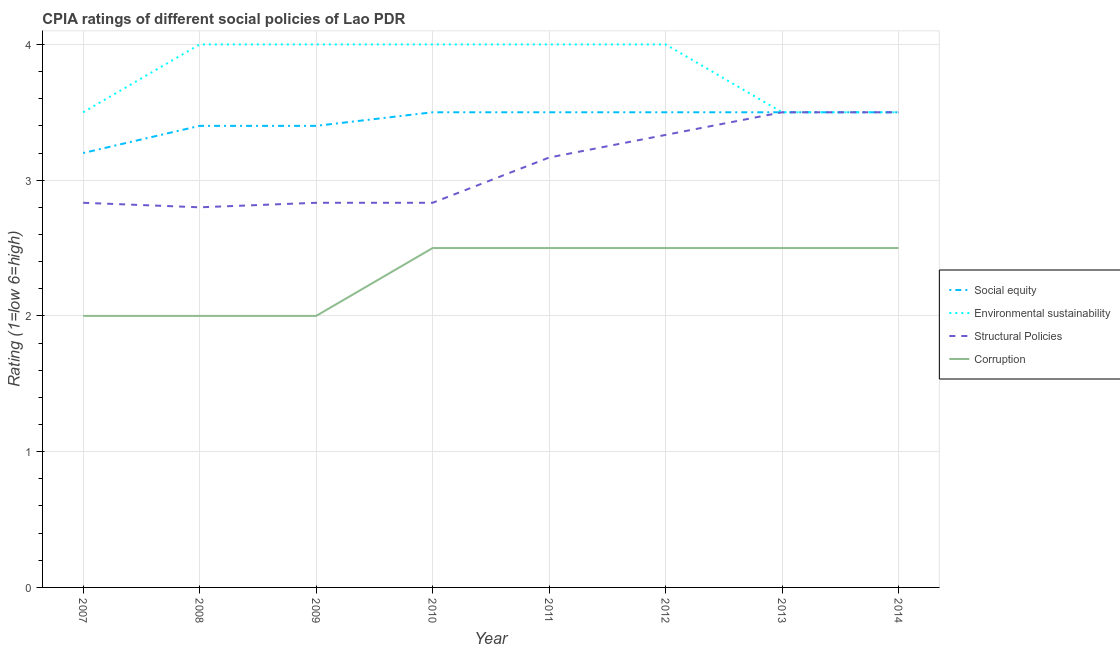How many different coloured lines are there?
Make the answer very short. 4. What is the cpia rating of corruption in 2014?
Give a very brief answer. 2.5. Across all years, what is the minimum cpia rating of structural policies?
Provide a short and direct response. 2.8. What is the total cpia rating of structural policies in the graph?
Your response must be concise. 24.8. What is the difference between the cpia rating of environmental sustainability in 2009 and that in 2012?
Provide a short and direct response. 0. What is the difference between the cpia rating of environmental sustainability in 2007 and the cpia rating of structural policies in 2010?
Ensure brevity in your answer.  0.67. What is the average cpia rating of social equity per year?
Offer a very short reply. 3.44. Is the difference between the cpia rating of environmental sustainability in 2009 and 2011 greater than the difference between the cpia rating of social equity in 2009 and 2011?
Your answer should be compact. Yes. What is the difference between the highest and the lowest cpia rating of social equity?
Ensure brevity in your answer.  0.3. In how many years, is the cpia rating of corruption greater than the average cpia rating of corruption taken over all years?
Your answer should be compact. 5. Is the sum of the cpia rating of environmental sustainability in 2008 and 2009 greater than the maximum cpia rating of corruption across all years?
Make the answer very short. Yes. Does the cpia rating of environmental sustainability monotonically increase over the years?
Offer a terse response. No. Is the cpia rating of corruption strictly less than the cpia rating of environmental sustainability over the years?
Keep it short and to the point. Yes. How many legend labels are there?
Your response must be concise. 4. How are the legend labels stacked?
Offer a very short reply. Vertical. What is the title of the graph?
Offer a terse response. CPIA ratings of different social policies of Lao PDR. What is the label or title of the Y-axis?
Make the answer very short. Rating (1=low 6=high). What is the Rating (1=low 6=high) of Structural Policies in 2007?
Provide a succinct answer. 2.83. What is the Rating (1=low 6=high) of Corruption in 2007?
Offer a very short reply. 2. What is the Rating (1=low 6=high) in Social equity in 2008?
Ensure brevity in your answer.  3.4. What is the Rating (1=low 6=high) in Environmental sustainability in 2008?
Your response must be concise. 4. What is the Rating (1=low 6=high) in Structural Policies in 2008?
Make the answer very short. 2.8. What is the Rating (1=low 6=high) in Environmental sustainability in 2009?
Your answer should be very brief. 4. What is the Rating (1=low 6=high) in Structural Policies in 2009?
Provide a short and direct response. 2.83. What is the Rating (1=low 6=high) in Structural Policies in 2010?
Your answer should be very brief. 2.83. What is the Rating (1=low 6=high) in Structural Policies in 2011?
Keep it short and to the point. 3.17. What is the Rating (1=low 6=high) of Environmental sustainability in 2012?
Your response must be concise. 4. What is the Rating (1=low 6=high) in Structural Policies in 2012?
Keep it short and to the point. 3.33. What is the Rating (1=low 6=high) in Social equity in 2013?
Ensure brevity in your answer.  3.5. What is the Rating (1=low 6=high) of Corruption in 2013?
Your response must be concise. 2.5. What is the Rating (1=low 6=high) in Structural Policies in 2014?
Your answer should be very brief. 3.5. Across all years, what is the maximum Rating (1=low 6=high) of Social equity?
Offer a terse response. 3.5. Across all years, what is the maximum Rating (1=low 6=high) in Structural Policies?
Make the answer very short. 3.5. Across all years, what is the maximum Rating (1=low 6=high) of Corruption?
Provide a short and direct response. 2.5. Across all years, what is the minimum Rating (1=low 6=high) in Environmental sustainability?
Give a very brief answer. 3.5. Across all years, what is the minimum Rating (1=low 6=high) in Structural Policies?
Offer a very short reply. 2.8. What is the total Rating (1=low 6=high) in Environmental sustainability in the graph?
Keep it short and to the point. 30.5. What is the total Rating (1=low 6=high) of Structural Policies in the graph?
Provide a short and direct response. 24.8. What is the difference between the Rating (1=low 6=high) in Environmental sustainability in 2007 and that in 2008?
Ensure brevity in your answer.  -0.5. What is the difference between the Rating (1=low 6=high) of Corruption in 2007 and that in 2008?
Make the answer very short. 0. What is the difference between the Rating (1=low 6=high) of Social equity in 2007 and that in 2009?
Give a very brief answer. -0.2. What is the difference between the Rating (1=low 6=high) in Corruption in 2007 and that in 2009?
Offer a very short reply. 0. What is the difference between the Rating (1=low 6=high) of Environmental sustainability in 2007 and that in 2010?
Your response must be concise. -0.5. What is the difference between the Rating (1=low 6=high) in Structural Policies in 2007 and that in 2010?
Make the answer very short. 0. What is the difference between the Rating (1=low 6=high) in Social equity in 2007 and that in 2011?
Your answer should be compact. -0.3. What is the difference between the Rating (1=low 6=high) in Structural Policies in 2007 and that in 2011?
Make the answer very short. -0.33. What is the difference between the Rating (1=low 6=high) in Environmental sustainability in 2007 and that in 2012?
Offer a terse response. -0.5. What is the difference between the Rating (1=low 6=high) of Corruption in 2007 and that in 2012?
Your answer should be very brief. -0.5. What is the difference between the Rating (1=low 6=high) in Environmental sustainability in 2007 and that in 2013?
Your answer should be compact. 0. What is the difference between the Rating (1=low 6=high) in Corruption in 2007 and that in 2013?
Give a very brief answer. -0.5. What is the difference between the Rating (1=low 6=high) in Social equity in 2007 and that in 2014?
Your response must be concise. -0.3. What is the difference between the Rating (1=low 6=high) of Social equity in 2008 and that in 2009?
Ensure brevity in your answer.  0. What is the difference between the Rating (1=low 6=high) of Structural Policies in 2008 and that in 2009?
Offer a very short reply. -0.03. What is the difference between the Rating (1=low 6=high) in Social equity in 2008 and that in 2010?
Your answer should be very brief. -0.1. What is the difference between the Rating (1=low 6=high) of Structural Policies in 2008 and that in 2010?
Ensure brevity in your answer.  -0.03. What is the difference between the Rating (1=low 6=high) of Social equity in 2008 and that in 2011?
Give a very brief answer. -0.1. What is the difference between the Rating (1=low 6=high) of Environmental sustainability in 2008 and that in 2011?
Ensure brevity in your answer.  0. What is the difference between the Rating (1=low 6=high) of Structural Policies in 2008 and that in 2011?
Your response must be concise. -0.37. What is the difference between the Rating (1=low 6=high) in Corruption in 2008 and that in 2011?
Ensure brevity in your answer.  -0.5. What is the difference between the Rating (1=low 6=high) of Social equity in 2008 and that in 2012?
Ensure brevity in your answer.  -0.1. What is the difference between the Rating (1=low 6=high) of Environmental sustainability in 2008 and that in 2012?
Give a very brief answer. 0. What is the difference between the Rating (1=low 6=high) of Structural Policies in 2008 and that in 2012?
Offer a terse response. -0.53. What is the difference between the Rating (1=low 6=high) of Environmental sustainability in 2008 and that in 2013?
Offer a very short reply. 0.5. What is the difference between the Rating (1=low 6=high) in Corruption in 2008 and that in 2013?
Offer a very short reply. -0.5. What is the difference between the Rating (1=low 6=high) of Environmental sustainability in 2008 and that in 2014?
Your answer should be compact. 0.5. What is the difference between the Rating (1=low 6=high) of Corruption in 2008 and that in 2014?
Make the answer very short. -0.5. What is the difference between the Rating (1=low 6=high) in Social equity in 2009 and that in 2010?
Offer a terse response. -0.1. What is the difference between the Rating (1=low 6=high) in Environmental sustainability in 2009 and that in 2010?
Offer a very short reply. 0. What is the difference between the Rating (1=low 6=high) of Corruption in 2009 and that in 2010?
Provide a succinct answer. -0.5. What is the difference between the Rating (1=low 6=high) in Social equity in 2009 and that in 2011?
Provide a succinct answer. -0.1. What is the difference between the Rating (1=low 6=high) in Structural Policies in 2009 and that in 2011?
Keep it short and to the point. -0.33. What is the difference between the Rating (1=low 6=high) of Corruption in 2009 and that in 2011?
Provide a short and direct response. -0.5. What is the difference between the Rating (1=low 6=high) in Social equity in 2009 and that in 2012?
Keep it short and to the point. -0.1. What is the difference between the Rating (1=low 6=high) in Environmental sustainability in 2009 and that in 2012?
Provide a succinct answer. 0. What is the difference between the Rating (1=low 6=high) in Corruption in 2009 and that in 2012?
Your answer should be very brief. -0.5. What is the difference between the Rating (1=low 6=high) in Structural Policies in 2009 and that in 2013?
Keep it short and to the point. -0.67. What is the difference between the Rating (1=low 6=high) in Social equity in 2009 and that in 2014?
Give a very brief answer. -0.1. What is the difference between the Rating (1=low 6=high) of Structural Policies in 2009 and that in 2014?
Give a very brief answer. -0.67. What is the difference between the Rating (1=low 6=high) of Social equity in 2010 and that in 2011?
Your response must be concise. 0. What is the difference between the Rating (1=low 6=high) in Environmental sustainability in 2010 and that in 2011?
Ensure brevity in your answer.  0. What is the difference between the Rating (1=low 6=high) of Structural Policies in 2010 and that in 2011?
Your answer should be compact. -0.33. What is the difference between the Rating (1=low 6=high) of Corruption in 2010 and that in 2011?
Your answer should be compact. 0. What is the difference between the Rating (1=low 6=high) of Environmental sustainability in 2010 and that in 2012?
Ensure brevity in your answer.  0. What is the difference between the Rating (1=low 6=high) of Corruption in 2010 and that in 2012?
Your response must be concise. 0. What is the difference between the Rating (1=low 6=high) of Environmental sustainability in 2010 and that in 2013?
Your response must be concise. 0.5. What is the difference between the Rating (1=low 6=high) in Structural Policies in 2010 and that in 2013?
Your response must be concise. -0.67. What is the difference between the Rating (1=low 6=high) in Corruption in 2010 and that in 2013?
Provide a short and direct response. 0. What is the difference between the Rating (1=low 6=high) of Social equity in 2010 and that in 2014?
Keep it short and to the point. 0. What is the difference between the Rating (1=low 6=high) of Structural Policies in 2010 and that in 2014?
Offer a very short reply. -0.67. What is the difference between the Rating (1=low 6=high) in Social equity in 2011 and that in 2012?
Your answer should be compact. 0. What is the difference between the Rating (1=low 6=high) in Environmental sustainability in 2011 and that in 2013?
Your answer should be compact. 0.5. What is the difference between the Rating (1=low 6=high) of Social equity in 2011 and that in 2014?
Provide a short and direct response. 0. What is the difference between the Rating (1=low 6=high) of Environmental sustainability in 2011 and that in 2014?
Provide a succinct answer. 0.5. What is the difference between the Rating (1=low 6=high) of Corruption in 2011 and that in 2014?
Your answer should be very brief. 0. What is the difference between the Rating (1=low 6=high) in Corruption in 2012 and that in 2014?
Give a very brief answer. 0. What is the difference between the Rating (1=low 6=high) in Social equity in 2013 and that in 2014?
Offer a very short reply. 0. What is the difference between the Rating (1=low 6=high) of Social equity in 2007 and the Rating (1=low 6=high) of Structural Policies in 2008?
Offer a very short reply. 0.4. What is the difference between the Rating (1=low 6=high) in Social equity in 2007 and the Rating (1=low 6=high) in Corruption in 2008?
Your answer should be compact. 1.2. What is the difference between the Rating (1=low 6=high) of Environmental sustainability in 2007 and the Rating (1=low 6=high) of Structural Policies in 2008?
Offer a terse response. 0.7. What is the difference between the Rating (1=low 6=high) of Environmental sustainability in 2007 and the Rating (1=low 6=high) of Corruption in 2008?
Offer a very short reply. 1.5. What is the difference between the Rating (1=low 6=high) in Structural Policies in 2007 and the Rating (1=low 6=high) in Corruption in 2008?
Keep it short and to the point. 0.83. What is the difference between the Rating (1=low 6=high) of Social equity in 2007 and the Rating (1=low 6=high) of Environmental sustainability in 2009?
Ensure brevity in your answer.  -0.8. What is the difference between the Rating (1=low 6=high) in Social equity in 2007 and the Rating (1=low 6=high) in Structural Policies in 2009?
Ensure brevity in your answer.  0.37. What is the difference between the Rating (1=low 6=high) of Environmental sustainability in 2007 and the Rating (1=low 6=high) of Structural Policies in 2009?
Offer a very short reply. 0.67. What is the difference between the Rating (1=low 6=high) of Environmental sustainability in 2007 and the Rating (1=low 6=high) of Corruption in 2009?
Provide a succinct answer. 1.5. What is the difference between the Rating (1=low 6=high) of Social equity in 2007 and the Rating (1=low 6=high) of Structural Policies in 2010?
Your response must be concise. 0.37. What is the difference between the Rating (1=low 6=high) in Social equity in 2007 and the Rating (1=low 6=high) in Corruption in 2010?
Ensure brevity in your answer.  0.7. What is the difference between the Rating (1=low 6=high) in Environmental sustainability in 2007 and the Rating (1=low 6=high) in Structural Policies in 2010?
Your answer should be very brief. 0.67. What is the difference between the Rating (1=low 6=high) in Structural Policies in 2007 and the Rating (1=low 6=high) in Corruption in 2010?
Your response must be concise. 0.33. What is the difference between the Rating (1=low 6=high) in Social equity in 2007 and the Rating (1=low 6=high) in Environmental sustainability in 2011?
Your answer should be very brief. -0.8. What is the difference between the Rating (1=low 6=high) of Environmental sustainability in 2007 and the Rating (1=low 6=high) of Structural Policies in 2011?
Provide a succinct answer. 0.33. What is the difference between the Rating (1=low 6=high) in Environmental sustainability in 2007 and the Rating (1=low 6=high) in Corruption in 2011?
Provide a succinct answer. 1. What is the difference between the Rating (1=low 6=high) of Structural Policies in 2007 and the Rating (1=low 6=high) of Corruption in 2011?
Offer a very short reply. 0.33. What is the difference between the Rating (1=low 6=high) in Social equity in 2007 and the Rating (1=low 6=high) in Structural Policies in 2012?
Provide a succinct answer. -0.13. What is the difference between the Rating (1=low 6=high) of Environmental sustainability in 2007 and the Rating (1=low 6=high) of Corruption in 2012?
Offer a very short reply. 1. What is the difference between the Rating (1=low 6=high) of Structural Policies in 2007 and the Rating (1=low 6=high) of Corruption in 2012?
Make the answer very short. 0.33. What is the difference between the Rating (1=low 6=high) of Social equity in 2007 and the Rating (1=low 6=high) of Environmental sustainability in 2013?
Provide a short and direct response. -0.3. What is the difference between the Rating (1=low 6=high) in Environmental sustainability in 2007 and the Rating (1=low 6=high) in Corruption in 2013?
Your response must be concise. 1. What is the difference between the Rating (1=low 6=high) in Social equity in 2007 and the Rating (1=low 6=high) in Corruption in 2014?
Ensure brevity in your answer.  0.7. What is the difference between the Rating (1=low 6=high) in Environmental sustainability in 2007 and the Rating (1=low 6=high) in Structural Policies in 2014?
Your response must be concise. 0. What is the difference between the Rating (1=low 6=high) in Environmental sustainability in 2007 and the Rating (1=low 6=high) in Corruption in 2014?
Your response must be concise. 1. What is the difference between the Rating (1=low 6=high) in Structural Policies in 2007 and the Rating (1=low 6=high) in Corruption in 2014?
Keep it short and to the point. 0.33. What is the difference between the Rating (1=low 6=high) in Social equity in 2008 and the Rating (1=low 6=high) in Environmental sustainability in 2009?
Provide a short and direct response. -0.6. What is the difference between the Rating (1=low 6=high) of Social equity in 2008 and the Rating (1=low 6=high) of Structural Policies in 2009?
Make the answer very short. 0.57. What is the difference between the Rating (1=low 6=high) of Environmental sustainability in 2008 and the Rating (1=low 6=high) of Structural Policies in 2009?
Your answer should be very brief. 1.17. What is the difference between the Rating (1=low 6=high) in Structural Policies in 2008 and the Rating (1=low 6=high) in Corruption in 2009?
Ensure brevity in your answer.  0.8. What is the difference between the Rating (1=low 6=high) of Social equity in 2008 and the Rating (1=low 6=high) of Structural Policies in 2010?
Your answer should be compact. 0.57. What is the difference between the Rating (1=low 6=high) of Environmental sustainability in 2008 and the Rating (1=low 6=high) of Structural Policies in 2010?
Provide a short and direct response. 1.17. What is the difference between the Rating (1=low 6=high) in Social equity in 2008 and the Rating (1=low 6=high) in Environmental sustainability in 2011?
Offer a terse response. -0.6. What is the difference between the Rating (1=low 6=high) in Social equity in 2008 and the Rating (1=low 6=high) in Structural Policies in 2011?
Offer a terse response. 0.23. What is the difference between the Rating (1=low 6=high) of Social equity in 2008 and the Rating (1=low 6=high) of Corruption in 2011?
Provide a succinct answer. 0.9. What is the difference between the Rating (1=low 6=high) of Social equity in 2008 and the Rating (1=low 6=high) of Environmental sustainability in 2012?
Give a very brief answer. -0.6. What is the difference between the Rating (1=low 6=high) in Social equity in 2008 and the Rating (1=low 6=high) in Structural Policies in 2012?
Keep it short and to the point. 0.07. What is the difference between the Rating (1=low 6=high) of Social equity in 2008 and the Rating (1=low 6=high) of Corruption in 2012?
Make the answer very short. 0.9. What is the difference between the Rating (1=low 6=high) in Environmental sustainability in 2008 and the Rating (1=low 6=high) in Structural Policies in 2012?
Make the answer very short. 0.67. What is the difference between the Rating (1=low 6=high) of Structural Policies in 2008 and the Rating (1=low 6=high) of Corruption in 2012?
Your answer should be compact. 0.3. What is the difference between the Rating (1=low 6=high) of Social equity in 2008 and the Rating (1=low 6=high) of Environmental sustainability in 2013?
Offer a terse response. -0.1. What is the difference between the Rating (1=low 6=high) in Structural Policies in 2008 and the Rating (1=low 6=high) in Corruption in 2013?
Provide a short and direct response. 0.3. What is the difference between the Rating (1=low 6=high) of Social equity in 2008 and the Rating (1=low 6=high) of Environmental sustainability in 2014?
Ensure brevity in your answer.  -0.1. What is the difference between the Rating (1=low 6=high) of Social equity in 2008 and the Rating (1=low 6=high) of Structural Policies in 2014?
Give a very brief answer. -0.1. What is the difference between the Rating (1=low 6=high) in Social equity in 2008 and the Rating (1=low 6=high) in Corruption in 2014?
Your answer should be compact. 0.9. What is the difference between the Rating (1=low 6=high) of Social equity in 2009 and the Rating (1=low 6=high) of Environmental sustainability in 2010?
Offer a very short reply. -0.6. What is the difference between the Rating (1=low 6=high) of Social equity in 2009 and the Rating (1=low 6=high) of Structural Policies in 2010?
Your answer should be compact. 0.57. What is the difference between the Rating (1=low 6=high) in Social equity in 2009 and the Rating (1=low 6=high) in Corruption in 2010?
Provide a succinct answer. 0.9. What is the difference between the Rating (1=low 6=high) of Environmental sustainability in 2009 and the Rating (1=low 6=high) of Corruption in 2010?
Keep it short and to the point. 1.5. What is the difference between the Rating (1=low 6=high) in Structural Policies in 2009 and the Rating (1=low 6=high) in Corruption in 2010?
Ensure brevity in your answer.  0.33. What is the difference between the Rating (1=low 6=high) in Social equity in 2009 and the Rating (1=low 6=high) in Environmental sustainability in 2011?
Make the answer very short. -0.6. What is the difference between the Rating (1=low 6=high) in Social equity in 2009 and the Rating (1=low 6=high) in Structural Policies in 2011?
Give a very brief answer. 0.23. What is the difference between the Rating (1=low 6=high) in Social equity in 2009 and the Rating (1=low 6=high) in Corruption in 2011?
Make the answer very short. 0.9. What is the difference between the Rating (1=low 6=high) in Environmental sustainability in 2009 and the Rating (1=low 6=high) in Corruption in 2011?
Provide a succinct answer. 1.5. What is the difference between the Rating (1=low 6=high) in Structural Policies in 2009 and the Rating (1=low 6=high) in Corruption in 2011?
Your answer should be compact. 0.33. What is the difference between the Rating (1=low 6=high) in Social equity in 2009 and the Rating (1=low 6=high) in Structural Policies in 2012?
Offer a terse response. 0.07. What is the difference between the Rating (1=low 6=high) in Environmental sustainability in 2009 and the Rating (1=low 6=high) in Structural Policies in 2012?
Offer a very short reply. 0.67. What is the difference between the Rating (1=low 6=high) of Structural Policies in 2009 and the Rating (1=low 6=high) of Corruption in 2012?
Ensure brevity in your answer.  0.33. What is the difference between the Rating (1=low 6=high) of Social equity in 2009 and the Rating (1=low 6=high) of Structural Policies in 2013?
Your answer should be compact. -0.1. What is the difference between the Rating (1=low 6=high) of Structural Policies in 2009 and the Rating (1=low 6=high) of Corruption in 2013?
Your response must be concise. 0.33. What is the difference between the Rating (1=low 6=high) in Social equity in 2009 and the Rating (1=low 6=high) in Structural Policies in 2014?
Give a very brief answer. -0.1. What is the difference between the Rating (1=low 6=high) of Environmental sustainability in 2009 and the Rating (1=low 6=high) of Corruption in 2014?
Your answer should be very brief. 1.5. What is the difference between the Rating (1=low 6=high) in Structural Policies in 2009 and the Rating (1=low 6=high) in Corruption in 2014?
Your answer should be very brief. 0.33. What is the difference between the Rating (1=low 6=high) of Environmental sustainability in 2010 and the Rating (1=low 6=high) of Structural Policies in 2011?
Your response must be concise. 0.83. What is the difference between the Rating (1=low 6=high) in Social equity in 2010 and the Rating (1=low 6=high) in Environmental sustainability in 2012?
Your response must be concise. -0.5. What is the difference between the Rating (1=low 6=high) in Social equity in 2010 and the Rating (1=low 6=high) in Corruption in 2012?
Offer a very short reply. 1. What is the difference between the Rating (1=low 6=high) in Environmental sustainability in 2010 and the Rating (1=low 6=high) in Corruption in 2012?
Offer a terse response. 1.5. What is the difference between the Rating (1=low 6=high) in Social equity in 2010 and the Rating (1=low 6=high) in Environmental sustainability in 2013?
Your answer should be compact. 0. What is the difference between the Rating (1=low 6=high) in Social equity in 2010 and the Rating (1=low 6=high) in Structural Policies in 2013?
Your answer should be very brief. 0. What is the difference between the Rating (1=low 6=high) in Social equity in 2010 and the Rating (1=low 6=high) in Corruption in 2013?
Give a very brief answer. 1. What is the difference between the Rating (1=low 6=high) of Social equity in 2010 and the Rating (1=low 6=high) of Structural Policies in 2014?
Offer a very short reply. 0. What is the difference between the Rating (1=low 6=high) in Environmental sustainability in 2010 and the Rating (1=low 6=high) in Corruption in 2014?
Make the answer very short. 1.5. What is the difference between the Rating (1=low 6=high) in Structural Policies in 2010 and the Rating (1=low 6=high) in Corruption in 2014?
Provide a short and direct response. 0.33. What is the difference between the Rating (1=low 6=high) in Social equity in 2011 and the Rating (1=low 6=high) in Environmental sustainability in 2012?
Make the answer very short. -0.5. What is the difference between the Rating (1=low 6=high) in Social equity in 2011 and the Rating (1=low 6=high) in Corruption in 2012?
Ensure brevity in your answer.  1. What is the difference between the Rating (1=low 6=high) in Environmental sustainability in 2011 and the Rating (1=low 6=high) in Structural Policies in 2012?
Offer a terse response. 0.67. What is the difference between the Rating (1=low 6=high) in Environmental sustainability in 2011 and the Rating (1=low 6=high) in Corruption in 2012?
Your response must be concise. 1.5. What is the difference between the Rating (1=low 6=high) of Social equity in 2011 and the Rating (1=low 6=high) of Environmental sustainability in 2013?
Ensure brevity in your answer.  0. What is the difference between the Rating (1=low 6=high) in Social equity in 2011 and the Rating (1=low 6=high) in Structural Policies in 2013?
Ensure brevity in your answer.  0. What is the difference between the Rating (1=low 6=high) of Environmental sustainability in 2011 and the Rating (1=low 6=high) of Structural Policies in 2013?
Keep it short and to the point. 0.5. What is the difference between the Rating (1=low 6=high) in Social equity in 2011 and the Rating (1=low 6=high) in Structural Policies in 2014?
Your response must be concise. 0. What is the difference between the Rating (1=low 6=high) in Social equity in 2012 and the Rating (1=low 6=high) in Structural Policies in 2013?
Your answer should be very brief. 0. What is the difference between the Rating (1=low 6=high) of Social equity in 2012 and the Rating (1=low 6=high) of Corruption in 2013?
Give a very brief answer. 1. What is the difference between the Rating (1=low 6=high) of Environmental sustainability in 2012 and the Rating (1=low 6=high) of Structural Policies in 2013?
Your answer should be compact. 0.5. What is the difference between the Rating (1=low 6=high) in Environmental sustainability in 2012 and the Rating (1=low 6=high) in Corruption in 2013?
Provide a short and direct response. 1.5. What is the difference between the Rating (1=low 6=high) of Structural Policies in 2012 and the Rating (1=low 6=high) of Corruption in 2013?
Provide a succinct answer. 0.83. What is the difference between the Rating (1=low 6=high) of Social equity in 2012 and the Rating (1=low 6=high) of Environmental sustainability in 2014?
Ensure brevity in your answer.  0. What is the difference between the Rating (1=low 6=high) in Social equity in 2012 and the Rating (1=low 6=high) in Corruption in 2014?
Offer a terse response. 1. What is the difference between the Rating (1=low 6=high) of Structural Policies in 2012 and the Rating (1=low 6=high) of Corruption in 2014?
Offer a very short reply. 0.83. What is the difference between the Rating (1=low 6=high) in Social equity in 2013 and the Rating (1=low 6=high) in Corruption in 2014?
Offer a very short reply. 1. What is the difference between the Rating (1=low 6=high) of Structural Policies in 2013 and the Rating (1=low 6=high) of Corruption in 2014?
Provide a succinct answer. 1. What is the average Rating (1=low 6=high) of Social equity per year?
Give a very brief answer. 3.44. What is the average Rating (1=low 6=high) in Environmental sustainability per year?
Keep it short and to the point. 3.81. What is the average Rating (1=low 6=high) in Corruption per year?
Your answer should be very brief. 2.31. In the year 2007, what is the difference between the Rating (1=low 6=high) of Social equity and Rating (1=low 6=high) of Structural Policies?
Your response must be concise. 0.37. In the year 2007, what is the difference between the Rating (1=low 6=high) of Social equity and Rating (1=low 6=high) of Corruption?
Your response must be concise. 1.2. In the year 2007, what is the difference between the Rating (1=low 6=high) in Environmental sustainability and Rating (1=low 6=high) in Corruption?
Make the answer very short. 1.5. In the year 2007, what is the difference between the Rating (1=low 6=high) of Structural Policies and Rating (1=low 6=high) of Corruption?
Provide a succinct answer. 0.83. In the year 2008, what is the difference between the Rating (1=low 6=high) in Social equity and Rating (1=low 6=high) in Structural Policies?
Provide a succinct answer. 0.6. In the year 2008, what is the difference between the Rating (1=low 6=high) of Social equity and Rating (1=low 6=high) of Corruption?
Provide a succinct answer. 1.4. In the year 2008, what is the difference between the Rating (1=low 6=high) of Structural Policies and Rating (1=low 6=high) of Corruption?
Offer a very short reply. 0.8. In the year 2009, what is the difference between the Rating (1=low 6=high) in Social equity and Rating (1=low 6=high) in Structural Policies?
Provide a short and direct response. 0.57. In the year 2009, what is the difference between the Rating (1=low 6=high) in Environmental sustainability and Rating (1=low 6=high) in Corruption?
Keep it short and to the point. 2. In the year 2009, what is the difference between the Rating (1=low 6=high) in Structural Policies and Rating (1=low 6=high) in Corruption?
Offer a very short reply. 0.83. In the year 2010, what is the difference between the Rating (1=low 6=high) of Social equity and Rating (1=low 6=high) of Structural Policies?
Your answer should be very brief. 0.67. In the year 2010, what is the difference between the Rating (1=low 6=high) in Social equity and Rating (1=low 6=high) in Corruption?
Ensure brevity in your answer.  1. In the year 2010, what is the difference between the Rating (1=low 6=high) in Environmental sustainability and Rating (1=low 6=high) in Structural Policies?
Provide a short and direct response. 1.17. In the year 2010, what is the difference between the Rating (1=low 6=high) of Environmental sustainability and Rating (1=low 6=high) of Corruption?
Give a very brief answer. 1.5. In the year 2010, what is the difference between the Rating (1=low 6=high) of Structural Policies and Rating (1=low 6=high) of Corruption?
Ensure brevity in your answer.  0.33. In the year 2011, what is the difference between the Rating (1=low 6=high) of Social equity and Rating (1=low 6=high) of Environmental sustainability?
Offer a terse response. -0.5. In the year 2011, what is the difference between the Rating (1=low 6=high) in Social equity and Rating (1=low 6=high) in Corruption?
Ensure brevity in your answer.  1. In the year 2011, what is the difference between the Rating (1=low 6=high) of Environmental sustainability and Rating (1=low 6=high) of Structural Policies?
Your answer should be very brief. 0.83. In the year 2011, what is the difference between the Rating (1=low 6=high) in Environmental sustainability and Rating (1=low 6=high) in Corruption?
Ensure brevity in your answer.  1.5. In the year 2011, what is the difference between the Rating (1=low 6=high) in Structural Policies and Rating (1=low 6=high) in Corruption?
Your response must be concise. 0.67. In the year 2012, what is the difference between the Rating (1=low 6=high) of Social equity and Rating (1=low 6=high) of Structural Policies?
Ensure brevity in your answer.  0.17. In the year 2012, what is the difference between the Rating (1=low 6=high) in Social equity and Rating (1=low 6=high) in Corruption?
Your response must be concise. 1. In the year 2013, what is the difference between the Rating (1=low 6=high) in Social equity and Rating (1=low 6=high) in Structural Policies?
Provide a short and direct response. 0. In the year 2013, what is the difference between the Rating (1=low 6=high) of Environmental sustainability and Rating (1=low 6=high) of Structural Policies?
Give a very brief answer. 0. In the year 2013, what is the difference between the Rating (1=low 6=high) in Structural Policies and Rating (1=low 6=high) in Corruption?
Keep it short and to the point. 1. In the year 2014, what is the difference between the Rating (1=low 6=high) of Social equity and Rating (1=low 6=high) of Structural Policies?
Ensure brevity in your answer.  0. In the year 2014, what is the difference between the Rating (1=low 6=high) of Environmental sustainability and Rating (1=low 6=high) of Corruption?
Your answer should be very brief. 1. In the year 2014, what is the difference between the Rating (1=low 6=high) of Structural Policies and Rating (1=low 6=high) of Corruption?
Your answer should be compact. 1. What is the ratio of the Rating (1=low 6=high) in Structural Policies in 2007 to that in 2008?
Your answer should be compact. 1.01. What is the ratio of the Rating (1=low 6=high) of Corruption in 2007 to that in 2008?
Your answer should be compact. 1. What is the ratio of the Rating (1=low 6=high) in Corruption in 2007 to that in 2009?
Provide a short and direct response. 1. What is the ratio of the Rating (1=low 6=high) in Social equity in 2007 to that in 2010?
Give a very brief answer. 0.91. What is the ratio of the Rating (1=low 6=high) in Corruption in 2007 to that in 2010?
Offer a very short reply. 0.8. What is the ratio of the Rating (1=low 6=high) of Social equity in 2007 to that in 2011?
Provide a succinct answer. 0.91. What is the ratio of the Rating (1=low 6=high) in Structural Policies in 2007 to that in 2011?
Your response must be concise. 0.89. What is the ratio of the Rating (1=low 6=high) of Corruption in 2007 to that in 2011?
Your answer should be compact. 0.8. What is the ratio of the Rating (1=low 6=high) in Social equity in 2007 to that in 2012?
Your response must be concise. 0.91. What is the ratio of the Rating (1=low 6=high) in Environmental sustainability in 2007 to that in 2012?
Offer a very short reply. 0.88. What is the ratio of the Rating (1=low 6=high) of Corruption in 2007 to that in 2012?
Your answer should be compact. 0.8. What is the ratio of the Rating (1=low 6=high) in Social equity in 2007 to that in 2013?
Give a very brief answer. 0.91. What is the ratio of the Rating (1=low 6=high) of Structural Policies in 2007 to that in 2013?
Your answer should be very brief. 0.81. What is the ratio of the Rating (1=low 6=high) in Corruption in 2007 to that in 2013?
Your answer should be very brief. 0.8. What is the ratio of the Rating (1=low 6=high) of Social equity in 2007 to that in 2014?
Make the answer very short. 0.91. What is the ratio of the Rating (1=low 6=high) in Structural Policies in 2007 to that in 2014?
Offer a very short reply. 0.81. What is the ratio of the Rating (1=low 6=high) of Corruption in 2007 to that in 2014?
Your answer should be very brief. 0.8. What is the ratio of the Rating (1=low 6=high) in Social equity in 2008 to that in 2010?
Give a very brief answer. 0.97. What is the ratio of the Rating (1=low 6=high) of Environmental sustainability in 2008 to that in 2010?
Your answer should be compact. 1. What is the ratio of the Rating (1=low 6=high) in Corruption in 2008 to that in 2010?
Your answer should be very brief. 0.8. What is the ratio of the Rating (1=low 6=high) of Social equity in 2008 to that in 2011?
Offer a very short reply. 0.97. What is the ratio of the Rating (1=low 6=high) in Environmental sustainability in 2008 to that in 2011?
Your answer should be compact. 1. What is the ratio of the Rating (1=low 6=high) in Structural Policies in 2008 to that in 2011?
Make the answer very short. 0.88. What is the ratio of the Rating (1=low 6=high) in Corruption in 2008 to that in 2011?
Offer a terse response. 0.8. What is the ratio of the Rating (1=low 6=high) of Social equity in 2008 to that in 2012?
Your answer should be very brief. 0.97. What is the ratio of the Rating (1=low 6=high) of Structural Policies in 2008 to that in 2012?
Keep it short and to the point. 0.84. What is the ratio of the Rating (1=low 6=high) in Social equity in 2008 to that in 2013?
Give a very brief answer. 0.97. What is the ratio of the Rating (1=low 6=high) in Environmental sustainability in 2008 to that in 2013?
Make the answer very short. 1.14. What is the ratio of the Rating (1=low 6=high) of Social equity in 2008 to that in 2014?
Offer a terse response. 0.97. What is the ratio of the Rating (1=low 6=high) in Environmental sustainability in 2008 to that in 2014?
Make the answer very short. 1.14. What is the ratio of the Rating (1=low 6=high) in Social equity in 2009 to that in 2010?
Give a very brief answer. 0.97. What is the ratio of the Rating (1=low 6=high) in Environmental sustainability in 2009 to that in 2010?
Provide a short and direct response. 1. What is the ratio of the Rating (1=low 6=high) of Structural Policies in 2009 to that in 2010?
Ensure brevity in your answer.  1. What is the ratio of the Rating (1=low 6=high) of Corruption in 2009 to that in 2010?
Your response must be concise. 0.8. What is the ratio of the Rating (1=low 6=high) in Social equity in 2009 to that in 2011?
Keep it short and to the point. 0.97. What is the ratio of the Rating (1=low 6=high) of Environmental sustainability in 2009 to that in 2011?
Offer a terse response. 1. What is the ratio of the Rating (1=low 6=high) in Structural Policies in 2009 to that in 2011?
Offer a very short reply. 0.89. What is the ratio of the Rating (1=low 6=high) in Corruption in 2009 to that in 2011?
Your response must be concise. 0.8. What is the ratio of the Rating (1=low 6=high) in Social equity in 2009 to that in 2012?
Your answer should be very brief. 0.97. What is the ratio of the Rating (1=low 6=high) of Environmental sustainability in 2009 to that in 2012?
Your response must be concise. 1. What is the ratio of the Rating (1=low 6=high) of Structural Policies in 2009 to that in 2012?
Offer a very short reply. 0.85. What is the ratio of the Rating (1=low 6=high) in Corruption in 2009 to that in 2012?
Your answer should be very brief. 0.8. What is the ratio of the Rating (1=low 6=high) in Social equity in 2009 to that in 2013?
Give a very brief answer. 0.97. What is the ratio of the Rating (1=low 6=high) of Structural Policies in 2009 to that in 2013?
Provide a succinct answer. 0.81. What is the ratio of the Rating (1=low 6=high) in Corruption in 2009 to that in 2013?
Your answer should be compact. 0.8. What is the ratio of the Rating (1=low 6=high) of Social equity in 2009 to that in 2014?
Make the answer very short. 0.97. What is the ratio of the Rating (1=low 6=high) in Environmental sustainability in 2009 to that in 2014?
Make the answer very short. 1.14. What is the ratio of the Rating (1=low 6=high) in Structural Policies in 2009 to that in 2014?
Make the answer very short. 0.81. What is the ratio of the Rating (1=low 6=high) in Structural Policies in 2010 to that in 2011?
Make the answer very short. 0.89. What is the ratio of the Rating (1=low 6=high) in Social equity in 2010 to that in 2012?
Give a very brief answer. 1. What is the ratio of the Rating (1=low 6=high) in Corruption in 2010 to that in 2012?
Give a very brief answer. 1. What is the ratio of the Rating (1=low 6=high) of Social equity in 2010 to that in 2013?
Ensure brevity in your answer.  1. What is the ratio of the Rating (1=low 6=high) in Environmental sustainability in 2010 to that in 2013?
Provide a short and direct response. 1.14. What is the ratio of the Rating (1=low 6=high) of Structural Policies in 2010 to that in 2013?
Your response must be concise. 0.81. What is the ratio of the Rating (1=low 6=high) of Corruption in 2010 to that in 2013?
Your answer should be very brief. 1. What is the ratio of the Rating (1=low 6=high) in Social equity in 2010 to that in 2014?
Offer a terse response. 1. What is the ratio of the Rating (1=low 6=high) of Environmental sustainability in 2010 to that in 2014?
Give a very brief answer. 1.14. What is the ratio of the Rating (1=low 6=high) in Structural Policies in 2010 to that in 2014?
Keep it short and to the point. 0.81. What is the ratio of the Rating (1=low 6=high) of Structural Policies in 2011 to that in 2012?
Provide a short and direct response. 0.95. What is the ratio of the Rating (1=low 6=high) of Corruption in 2011 to that in 2012?
Make the answer very short. 1. What is the ratio of the Rating (1=low 6=high) of Social equity in 2011 to that in 2013?
Your answer should be compact. 1. What is the ratio of the Rating (1=low 6=high) of Environmental sustainability in 2011 to that in 2013?
Your answer should be very brief. 1.14. What is the ratio of the Rating (1=low 6=high) of Structural Policies in 2011 to that in 2013?
Your answer should be very brief. 0.9. What is the ratio of the Rating (1=low 6=high) in Corruption in 2011 to that in 2013?
Ensure brevity in your answer.  1. What is the ratio of the Rating (1=low 6=high) in Structural Policies in 2011 to that in 2014?
Your response must be concise. 0.9. What is the ratio of the Rating (1=low 6=high) in Corruption in 2011 to that in 2014?
Make the answer very short. 1. What is the ratio of the Rating (1=low 6=high) of Environmental sustainability in 2012 to that in 2013?
Ensure brevity in your answer.  1.14. What is the ratio of the Rating (1=low 6=high) of Social equity in 2012 to that in 2014?
Ensure brevity in your answer.  1. What is the ratio of the Rating (1=low 6=high) in Environmental sustainability in 2012 to that in 2014?
Your answer should be very brief. 1.14. What is the ratio of the Rating (1=low 6=high) of Environmental sustainability in 2013 to that in 2014?
Provide a short and direct response. 1. What is the ratio of the Rating (1=low 6=high) of Structural Policies in 2013 to that in 2014?
Keep it short and to the point. 1. What is the difference between the highest and the second highest Rating (1=low 6=high) in Structural Policies?
Keep it short and to the point. 0. What is the difference between the highest and the lowest Rating (1=low 6=high) of Environmental sustainability?
Offer a very short reply. 0.5. What is the difference between the highest and the lowest Rating (1=low 6=high) in Corruption?
Your answer should be compact. 0.5. 